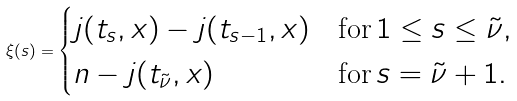<formula> <loc_0><loc_0><loc_500><loc_500>\xi ( s ) = \begin{cases} j ( t _ { s } , x ) - j ( t _ { s - 1 } , x ) & \text {for} \, 1 \leq s \leq \tilde { \nu } , \\ n - j ( t _ { \tilde { \nu } } , x ) & \text {for} \, s = \tilde { \nu } + 1 . \end{cases}</formula> 